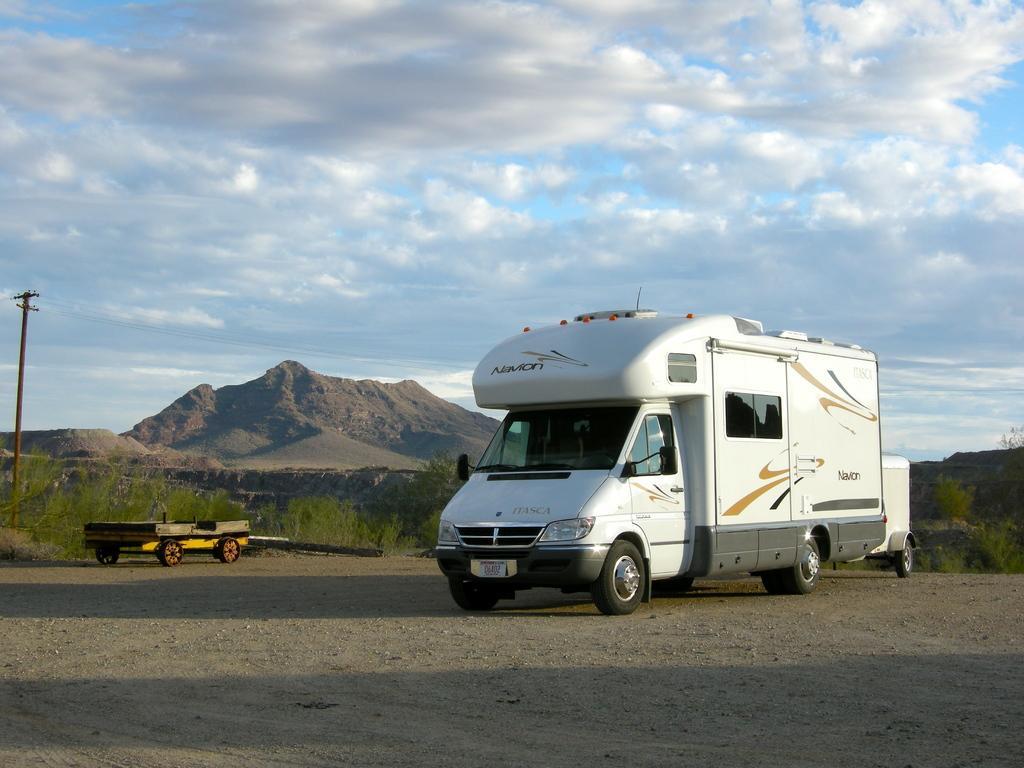Please provide a concise description of this image. Here in this picture we can see a van present on the ground over there and beside that we can see a trolley also present and we can see plants present all over there and we can see an electrical pole present and in the far we can see mountains present and we can see clouds in the sky over there. 